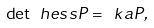Convert formula to latex. <formula><loc_0><loc_0><loc_500><loc_500>\det \ h e s s P = \ k a P ,</formula> 